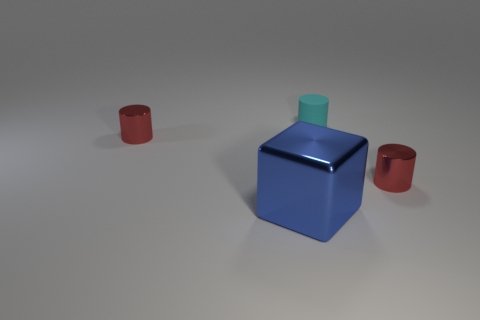Add 4 small red metal objects. How many objects exist? 8 Subtract all cylinders. How many objects are left? 1 Add 4 small cyan objects. How many small cyan objects exist? 5 Subtract 0 red spheres. How many objects are left? 4 Subtract all tiny cyan matte cylinders. Subtract all large blue metallic things. How many objects are left? 2 Add 3 tiny red shiny things. How many tiny red shiny things are left? 5 